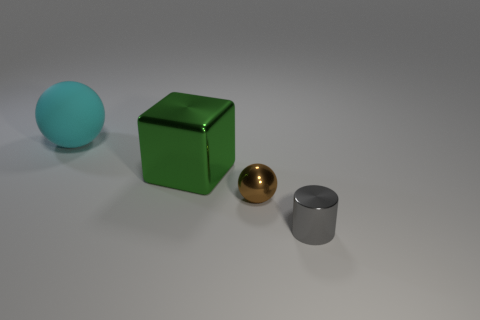Add 2 small rubber spheres. How many objects exist? 6 Subtract all cubes. How many objects are left? 3 Add 2 tiny brown balls. How many tiny brown balls exist? 3 Subtract 0 red blocks. How many objects are left? 4 Subtract all gray shiny cylinders. Subtract all tiny spheres. How many objects are left? 2 Add 2 big things. How many big things are left? 4 